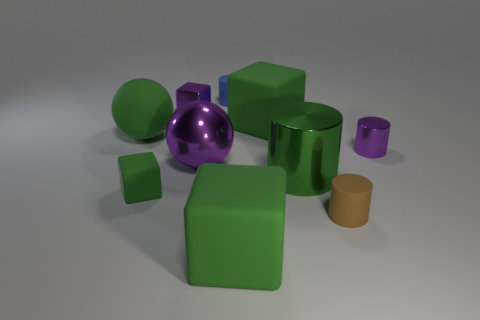Is there a small metal object of the same color as the tiny metal cylinder?
Offer a terse response. Yes. There is a purple object right of the small brown rubber object; what is its material?
Provide a succinct answer. Metal. There is a small cube that is made of the same material as the blue thing; what color is it?
Keep it short and to the point. Green. How many purple things are the same size as the purple cube?
Offer a terse response. 1. There is a purple metal object right of the blue cylinder; is it the same size as the large green metallic object?
Offer a terse response. No. The green matte object that is in front of the green sphere and on the left side of the purple shiny cube has what shape?
Offer a very short reply. Cube. There is a large green shiny cylinder; are there any objects in front of it?
Offer a terse response. Yes. Is there anything else that has the same shape as the big green metallic thing?
Provide a succinct answer. Yes. Does the small brown thing have the same shape as the small green matte object?
Offer a terse response. No. Are there an equal number of large green rubber objects that are to the left of the brown matte thing and big green blocks that are left of the tiny green cube?
Ensure brevity in your answer.  No. 